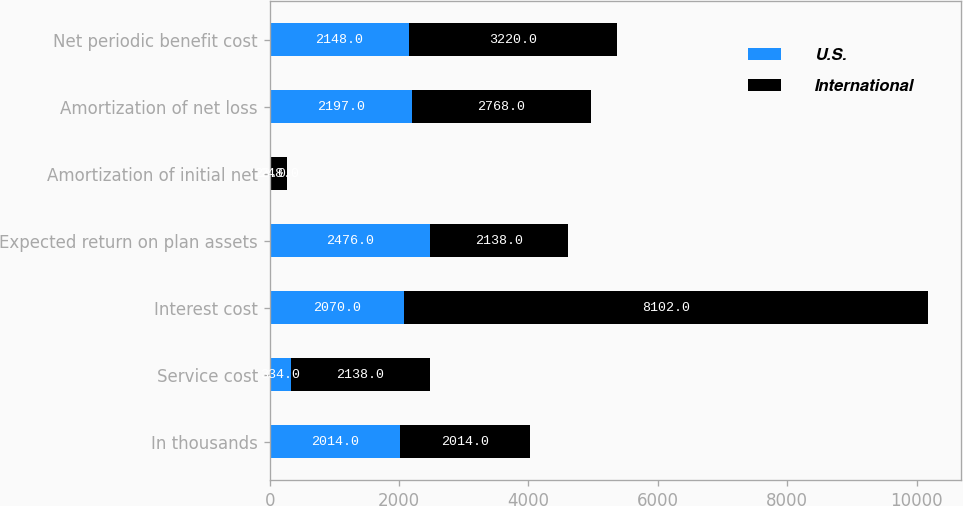<chart> <loc_0><loc_0><loc_500><loc_500><stacked_bar_chart><ecel><fcel>In thousands<fcel>Service cost<fcel>Interest cost<fcel>Expected return on plan assets<fcel>Amortization of initial net<fcel>Amortization of net loss<fcel>Net periodic benefit cost<nl><fcel>U.S.<fcel>2014<fcel>334<fcel>2070<fcel>2476<fcel>23<fcel>2197<fcel>2148<nl><fcel>International<fcel>2014<fcel>2138<fcel>8102<fcel>2138<fcel>248<fcel>2768<fcel>3220<nl></chart> 